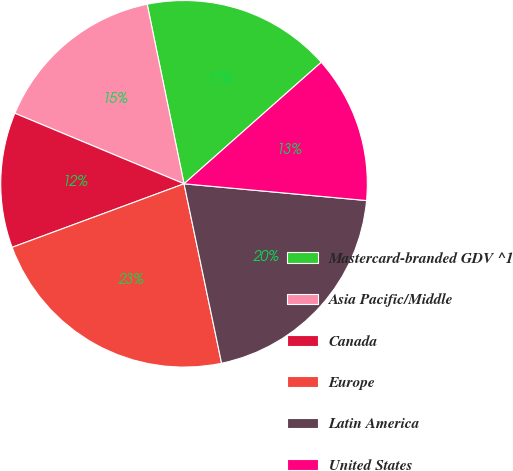Convert chart. <chart><loc_0><loc_0><loc_500><loc_500><pie_chart><fcel>Mastercard-branded GDV ^1<fcel>Asia Pacific/Middle<fcel>Canada<fcel>Europe<fcel>Latin America<fcel>United States<nl><fcel>16.69%<fcel>15.49%<fcel>11.92%<fcel>22.65%<fcel>20.26%<fcel>12.99%<nl></chart> 